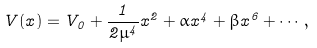<formula> <loc_0><loc_0><loc_500><loc_500>V ( x ) = V _ { 0 } + \frac { 1 } { 2 \mu ^ { 4 } } x ^ { 2 } + \alpha x ^ { 4 } + \beta x ^ { 6 } + \cdots ,</formula> 